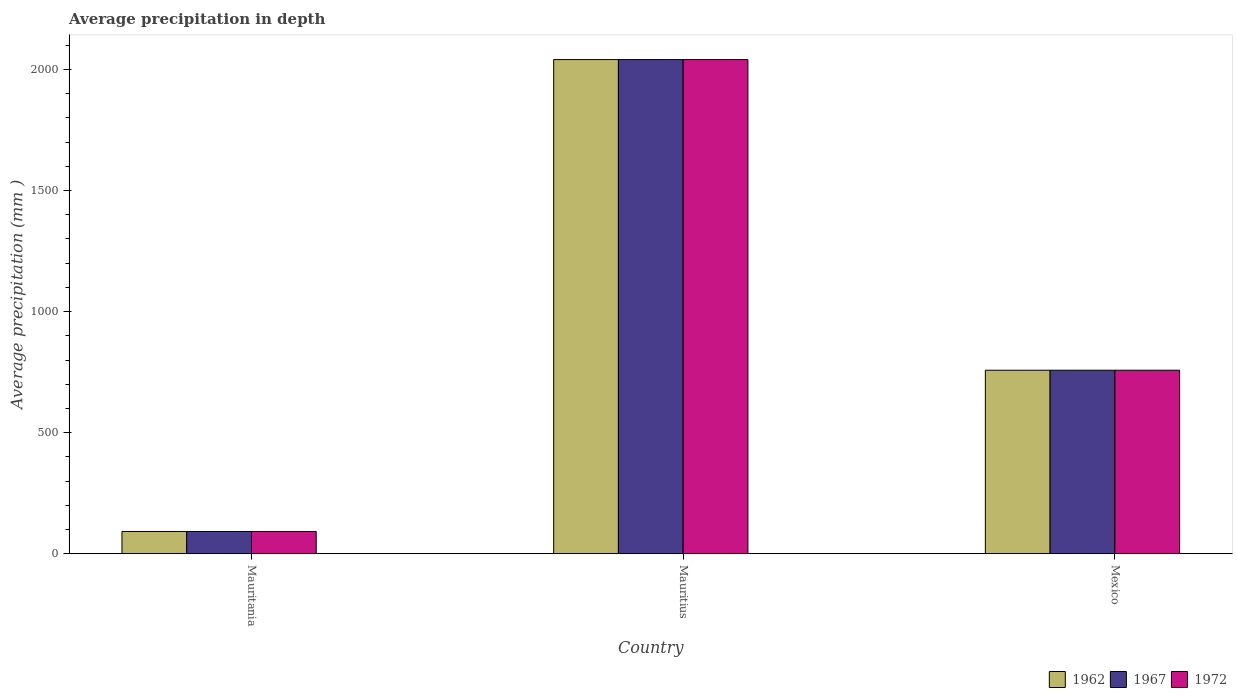How many different coloured bars are there?
Make the answer very short. 3. How many groups of bars are there?
Your response must be concise. 3. What is the label of the 1st group of bars from the left?
Make the answer very short. Mauritania. In how many cases, is the number of bars for a given country not equal to the number of legend labels?
Ensure brevity in your answer.  0. What is the average precipitation in 1962 in Mauritius?
Provide a succinct answer. 2041. Across all countries, what is the maximum average precipitation in 1962?
Make the answer very short. 2041. Across all countries, what is the minimum average precipitation in 1967?
Provide a succinct answer. 92. In which country was the average precipitation in 1967 maximum?
Provide a short and direct response. Mauritius. In which country was the average precipitation in 1962 minimum?
Your answer should be very brief. Mauritania. What is the total average precipitation in 1962 in the graph?
Your answer should be compact. 2891. What is the difference between the average precipitation in 1967 in Mauritania and that in Mexico?
Provide a short and direct response. -666. What is the difference between the average precipitation in 1967 in Mauritius and the average precipitation in 1962 in Mexico?
Give a very brief answer. 1283. What is the average average precipitation in 1962 per country?
Provide a succinct answer. 963.67. In how many countries, is the average precipitation in 1967 greater than 1500 mm?
Keep it short and to the point. 1. What is the ratio of the average precipitation in 1962 in Mauritius to that in Mexico?
Give a very brief answer. 2.69. Is the average precipitation in 1962 in Mauritania less than that in Mexico?
Your answer should be very brief. Yes. Is the difference between the average precipitation in 1967 in Mauritania and Mexico greater than the difference between the average precipitation in 1972 in Mauritania and Mexico?
Ensure brevity in your answer.  No. What is the difference between the highest and the second highest average precipitation in 1962?
Your response must be concise. 1949. What is the difference between the highest and the lowest average precipitation in 1967?
Your response must be concise. 1949. Is the sum of the average precipitation in 1962 in Mauritania and Mauritius greater than the maximum average precipitation in 1967 across all countries?
Your answer should be compact. Yes. What does the 1st bar from the left in Mexico represents?
Offer a very short reply. 1962. Is it the case that in every country, the sum of the average precipitation in 1972 and average precipitation in 1962 is greater than the average precipitation in 1967?
Your answer should be very brief. Yes. Are all the bars in the graph horizontal?
Provide a short and direct response. No. Where does the legend appear in the graph?
Provide a short and direct response. Bottom right. What is the title of the graph?
Offer a very short reply. Average precipitation in depth. What is the label or title of the X-axis?
Provide a succinct answer. Country. What is the label or title of the Y-axis?
Your response must be concise. Average precipitation (mm ). What is the Average precipitation (mm ) in 1962 in Mauritania?
Offer a very short reply. 92. What is the Average precipitation (mm ) of 1967 in Mauritania?
Keep it short and to the point. 92. What is the Average precipitation (mm ) in 1972 in Mauritania?
Your answer should be very brief. 92. What is the Average precipitation (mm ) in 1962 in Mauritius?
Ensure brevity in your answer.  2041. What is the Average precipitation (mm ) in 1967 in Mauritius?
Make the answer very short. 2041. What is the Average precipitation (mm ) in 1972 in Mauritius?
Your answer should be compact. 2041. What is the Average precipitation (mm ) in 1962 in Mexico?
Offer a terse response. 758. What is the Average precipitation (mm ) of 1967 in Mexico?
Offer a terse response. 758. What is the Average precipitation (mm ) in 1972 in Mexico?
Ensure brevity in your answer.  758. Across all countries, what is the maximum Average precipitation (mm ) in 1962?
Give a very brief answer. 2041. Across all countries, what is the maximum Average precipitation (mm ) in 1967?
Your response must be concise. 2041. Across all countries, what is the maximum Average precipitation (mm ) of 1972?
Make the answer very short. 2041. Across all countries, what is the minimum Average precipitation (mm ) in 1962?
Ensure brevity in your answer.  92. Across all countries, what is the minimum Average precipitation (mm ) in 1967?
Provide a succinct answer. 92. Across all countries, what is the minimum Average precipitation (mm ) in 1972?
Ensure brevity in your answer.  92. What is the total Average precipitation (mm ) in 1962 in the graph?
Offer a terse response. 2891. What is the total Average precipitation (mm ) of 1967 in the graph?
Give a very brief answer. 2891. What is the total Average precipitation (mm ) in 1972 in the graph?
Provide a short and direct response. 2891. What is the difference between the Average precipitation (mm ) in 1962 in Mauritania and that in Mauritius?
Ensure brevity in your answer.  -1949. What is the difference between the Average precipitation (mm ) of 1967 in Mauritania and that in Mauritius?
Make the answer very short. -1949. What is the difference between the Average precipitation (mm ) of 1972 in Mauritania and that in Mauritius?
Your response must be concise. -1949. What is the difference between the Average precipitation (mm ) of 1962 in Mauritania and that in Mexico?
Offer a very short reply. -666. What is the difference between the Average precipitation (mm ) of 1967 in Mauritania and that in Mexico?
Provide a succinct answer. -666. What is the difference between the Average precipitation (mm ) in 1972 in Mauritania and that in Mexico?
Your answer should be compact. -666. What is the difference between the Average precipitation (mm ) in 1962 in Mauritius and that in Mexico?
Provide a short and direct response. 1283. What is the difference between the Average precipitation (mm ) in 1967 in Mauritius and that in Mexico?
Your answer should be compact. 1283. What is the difference between the Average precipitation (mm ) in 1972 in Mauritius and that in Mexico?
Offer a terse response. 1283. What is the difference between the Average precipitation (mm ) in 1962 in Mauritania and the Average precipitation (mm ) in 1967 in Mauritius?
Provide a short and direct response. -1949. What is the difference between the Average precipitation (mm ) in 1962 in Mauritania and the Average precipitation (mm ) in 1972 in Mauritius?
Your response must be concise. -1949. What is the difference between the Average precipitation (mm ) in 1967 in Mauritania and the Average precipitation (mm ) in 1972 in Mauritius?
Provide a succinct answer. -1949. What is the difference between the Average precipitation (mm ) in 1962 in Mauritania and the Average precipitation (mm ) in 1967 in Mexico?
Your response must be concise. -666. What is the difference between the Average precipitation (mm ) of 1962 in Mauritania and the Average precipitation (mm ) of 1972 in Mexico?
Give a very brief answer. -666. What is the difference between the Average precipitation (mm ) of 1967 in Mauritania and the Average precipitation (mm ) of 1972 in Mexico?
Make the answer very short. -666. What is the difference between the Average precipitation (mm ) of 1962 in Mauritius and the Average precipitation (mm ) of 1967 in Mexico?
Keep it short and to the point. 1283. What is the difference between the Average precipitation (mm ) in 1962 in Mauritius and the Average precipitation (mm ) in 1972 in Mexico?
Offer a terse response. 1283. What is the difference between the Average precipitation (mm ) of 1967 in Mauritius and the Average precipitation (mm ) of 1972 in Mexico?
Your answer should be very brief. 1283. What is the average Average precipitation (mm ) in 1962 per country?
Your response must be concise. 963.67. What is the average Average precipitation (mm ) of 1967 per country?
Your answer should be very brief. 963.67. What is the average Average precipitation (mm ) of 1972 per country?
Your response must be concise. 963.67. What is the difference between the Average precipitation (mm ) in 1962 and Average precipitation (mm ) in 1972 in Mauritania?
Your response must be concise. 0. What is the difference between the Average precipitation (mm ) of 1967 and Average precipitation (mm ) of 1972 in Mauritania?
Give a very brief answer. 0. What is the difference between the Average precipitation (mm ) of 1962 and Average precipitation (mm ) of 1967 in Mauritius?
Your answer should be compact. 0. What is the difference between the Average precipitation (mm ) in 1962 and Average precipitation (mm ) in 1967 in Mexico?
Provide a succinct answer. 0. What is the ratio of the Average precipitation (mm ) in 1962 in Mauritania to that in Mauritius?
Provide a succinct answer. 0.05. What is the ratio of the Average precipitation (mm ) in 1967 in Mauritania to that in Mauritius?
Your answer should be very brief. 0.05. What is the ratio of the Average precipitation (mm ) of 1972 in Mauritania to that in Mauritius?
Your answer should be compact. 0.05. What is the ratio of the Average precipitation (mm ) of 1962 in Mauritania to that in Mexico?
Keep it short and to the point. 0.12. What is the ratio of the Average precipitation (mm ) of 1967 in Mauritania to that in Mexico?
Ensure brevity in your answer.  0.12. What is the ratio of the Average precipitation (mm ) of 1972 in Mauritania to that in Mexico?
Offer a terse response. 0.12. What is the ratio of the Average precipitation (mm ) of 1962 in Mauritius to that in Mexico?
Offer a terse response. 2.69. What is the ratio of the Average precipitation (mm ) of 1967 in Mauritius to that in Mexico?
Your answer should be very brief. 2.69. What is the ratio of the Average precipitation (mm ) in 1972 in Mauritius to that in Mexico?
Keep it short and to the point. 2.69. What is the difference between the highest and the second highest Average precipitation (mm ) of 1962?
Make the answer very short. 1283. What is the difference between the highest and the second highest Average precipitation (mm ) of 1967?
Ensure brevity in your answer.  1283. What is the difference between the highest and the second highest Average precipitation (mm ) of 1972?
Your response must be concise. 1283. What is the difference between the highest and the lowest Average precipitation (mm ) in 1962?
Your response must be concise. 1949. What is the difference between the highest and the lowest Average precipitation (mm ) of 1967?
Keep it short and to the point. 1949. What is the difference between the highest and the lowest Average precipitation (mm ) of 1972?
Make the answer very short. 1949. 